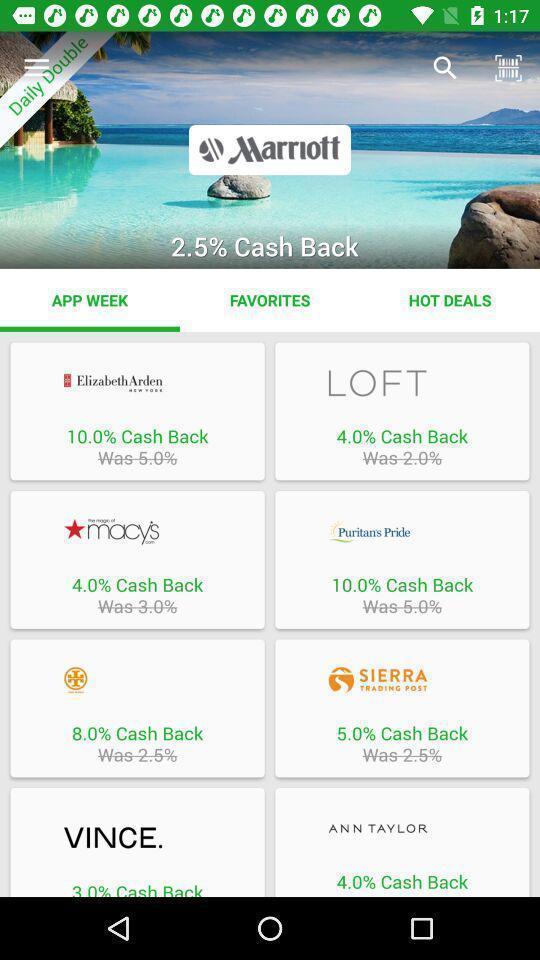Summarize the main components in this picture. Screen displaying multiple shopping brand names. 